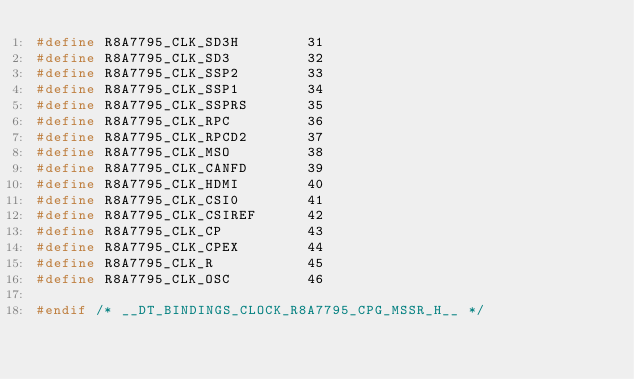Convert code to text. <code><loc_0><loc_0><loc_500><loc_500><_C_>#define R8A7795_CLK_SD3H		31
#define R8A7795_CLK_SD3			32
#define R8A7795_CLK_SSP2		33
#define R8A7795_CLK_SSP1		34
#define R8A7795_CLK_SSPRS		35
#define R8A7795_CLK_RPC			36
#define R8A7795_CLK_RPCD2		37
#define R8A7795_CLK_MSO			38
#define R8A7795_CLK_CANFD		39
#define R8A7795_CLK_HDMI		40
#define R8A7795_CLK_CSI0		41
#define R8A7795_CLK_CSIREF		42
#define R8A7795_CLK_CP			43
#define R8A7795_CLK_CPEX		44
#define R8A7795_CLK_R			45
#define R8A7795_CLK_OSC			46

#endif /* __DT_BINDINGS_CLOCK_R8A7795_CPG_MSSR_H__ */
</code> 